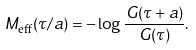<formula> <loc_0><loc_0><loc_500><loc_500>M _ { \text {eff} } ( \tau / a ) = - \log \frac { G ( \tau + a ) } { G ( \tau ) } .</formula> 